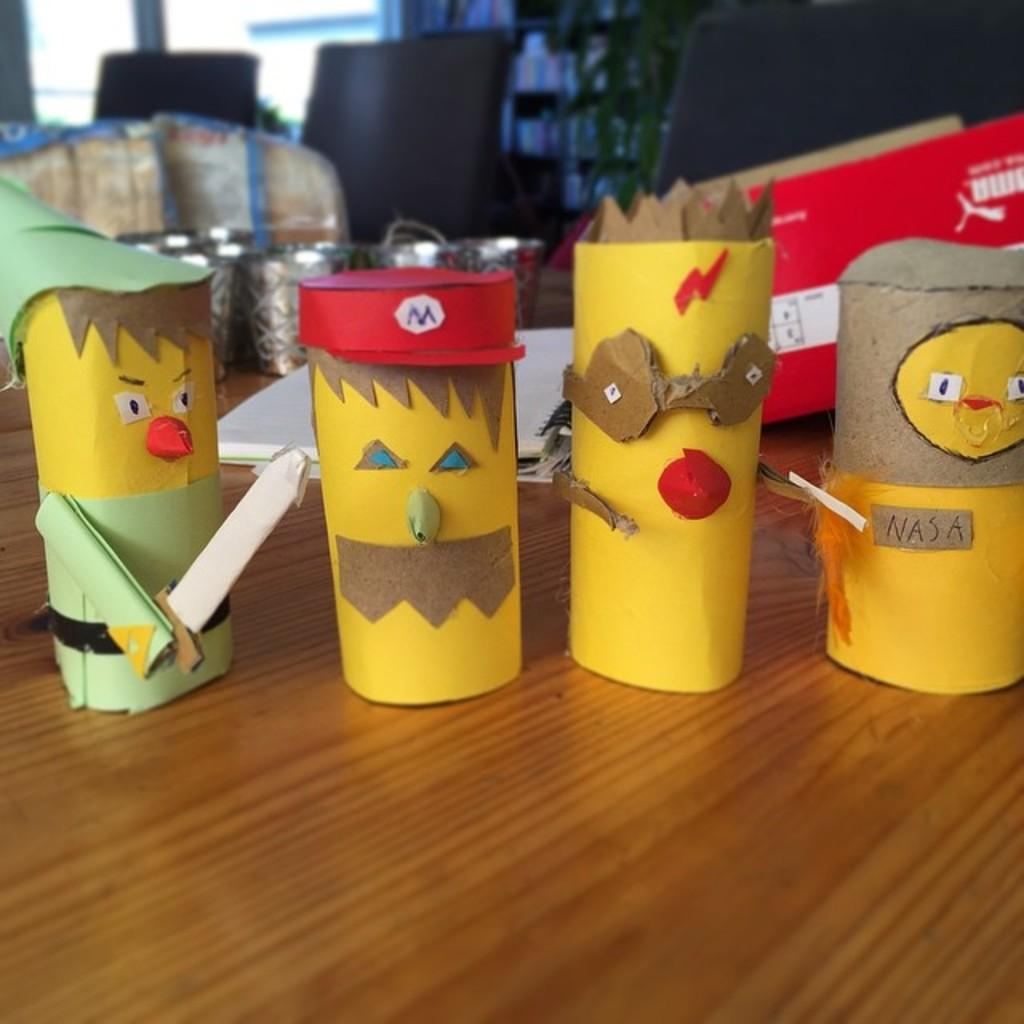What type of table is in the foreground of the image? There is a wooden table in the foreground of the image. What items can be seen on the table? Paper toys, books, a box, jars, desktops, and various objects are present on the table. Can you describe the window in the background of the image? There is a window in the background of the image, but no specific details about the window are provided. What degree of difficulty is required to push the jars off the table in the image? There is no information provided about the jars' weight or the table's stability, so it is impossible to determine the degree of difficulty required to push the jars off the table. 